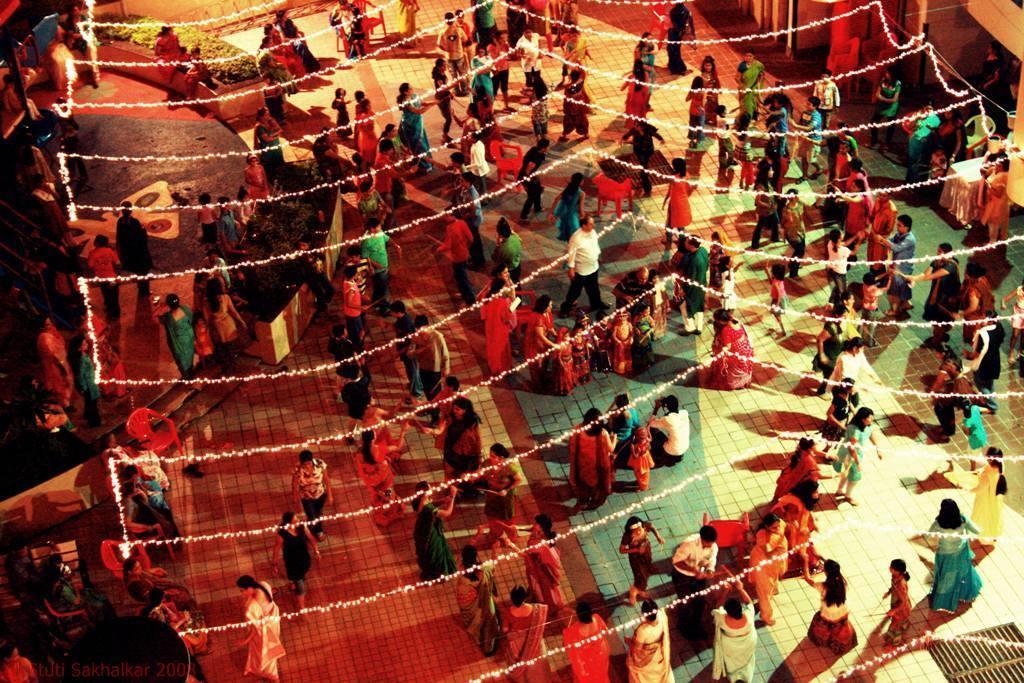How would you summarize this image in a sentence or two? In this image few persons are standing on the floor. Few persons are dancing. Top of image there are few plants , beside few persons are sitting. There are few lights at the front side of image. Right side there is a table , beside there is a chair. Few persons are standing near the table. 